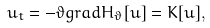Convert formula to latex. <formula><loc_0><loc_0><loc_500><loc_500>u _ { t } = - \vartheta g r a d H _ { \vartheta } [ u ] = K [ u ] ,</formula> 